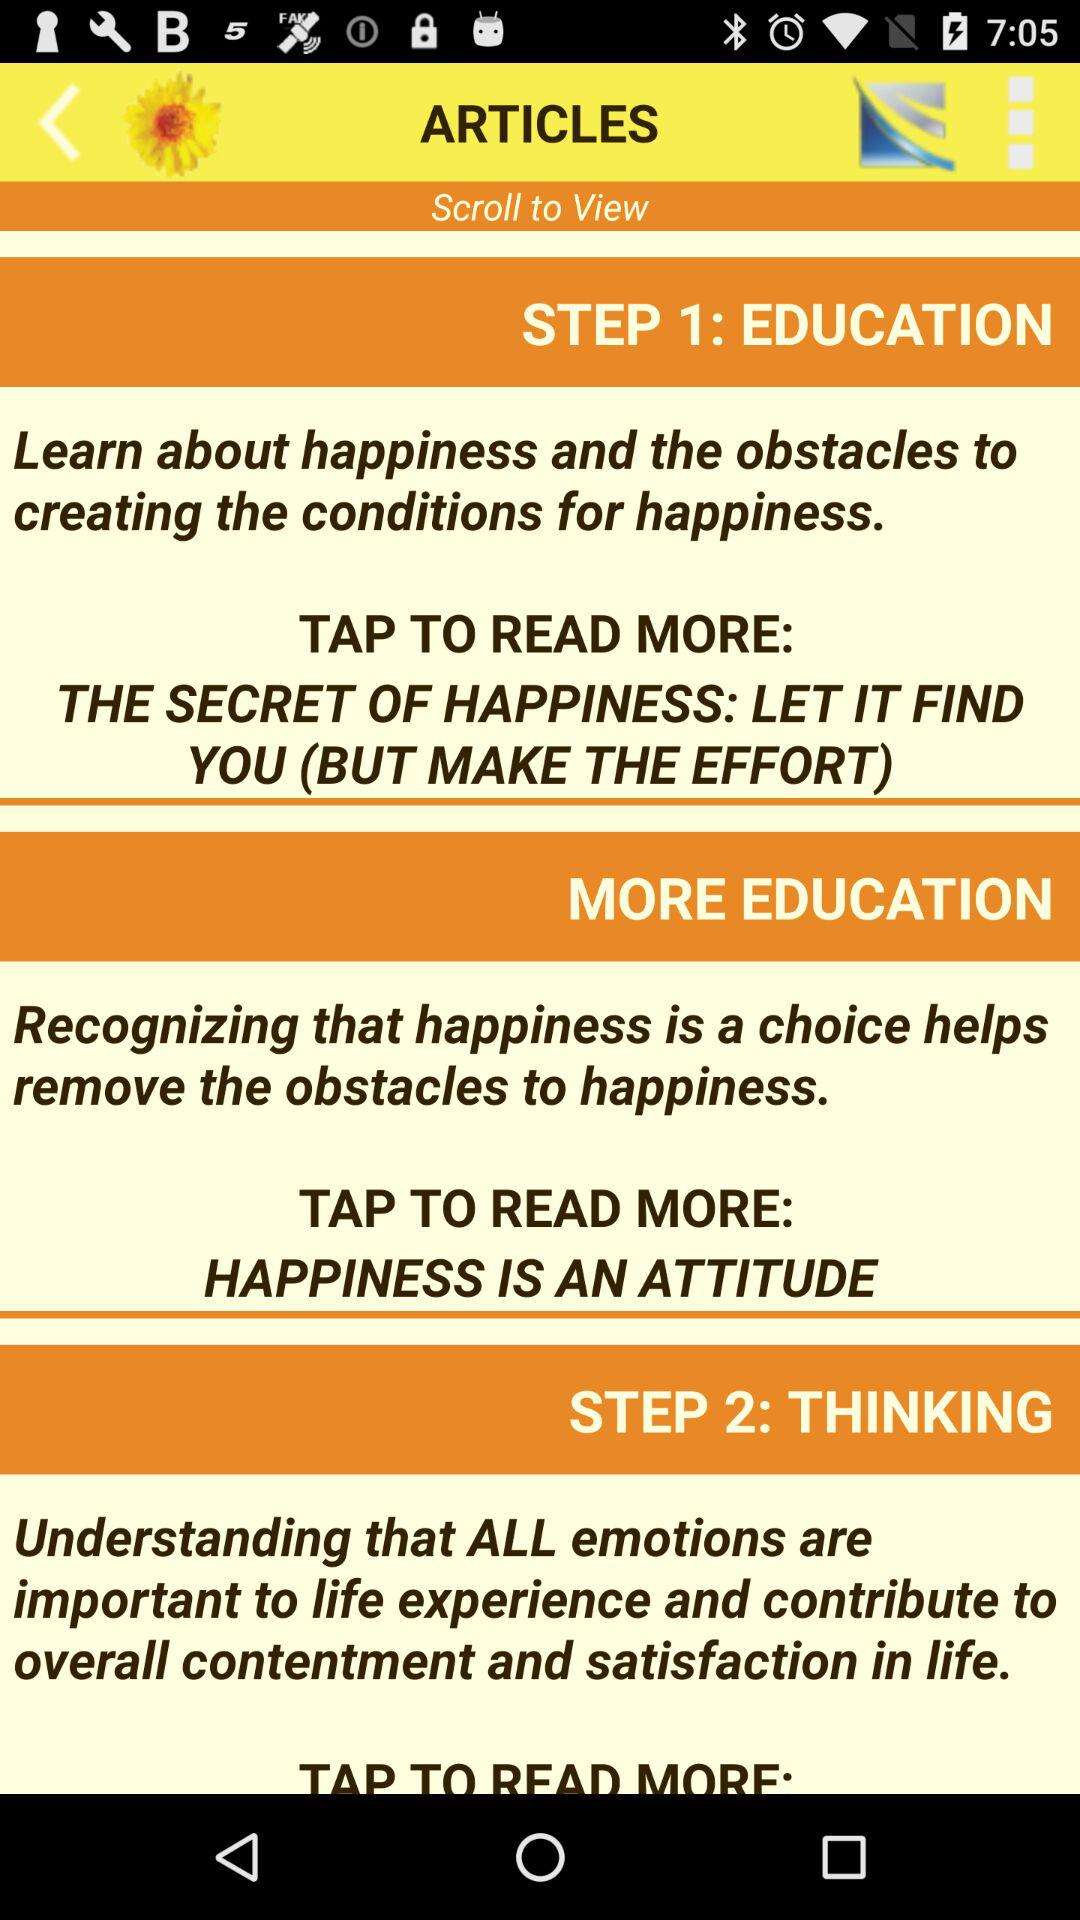What is step 3?
When the provided information is insufficient, respond with <no answer>. <no answer> 